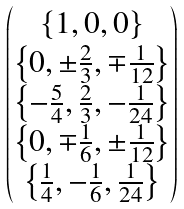<formula> <loc_0><loc_0><loc_500><loc_500>\begin{pmatrix} \left \{ 1 , 0 , 0 \right \} \\ \left \{ 0 , \pm \frac { 2 } { 3 } , \mp \frac { 1 } { 1 2 } \right \} \\ \left \{ - \frac { 5 } { 4 } , \frac { 2 } { 3 } , - \frac { 1 } { 2 4 } \right \} \\ \left \{ 0 , \mp \frac { 1 } { 6 } , \pm \frac { 1 } { 1 2 } \right \} \\ \left \{ \frac { 1 } { 4 } , - \frac { 1 } { 6 } , \frac { 1 } { 2 4 } \right \} \end{pmatrix}</formula> 